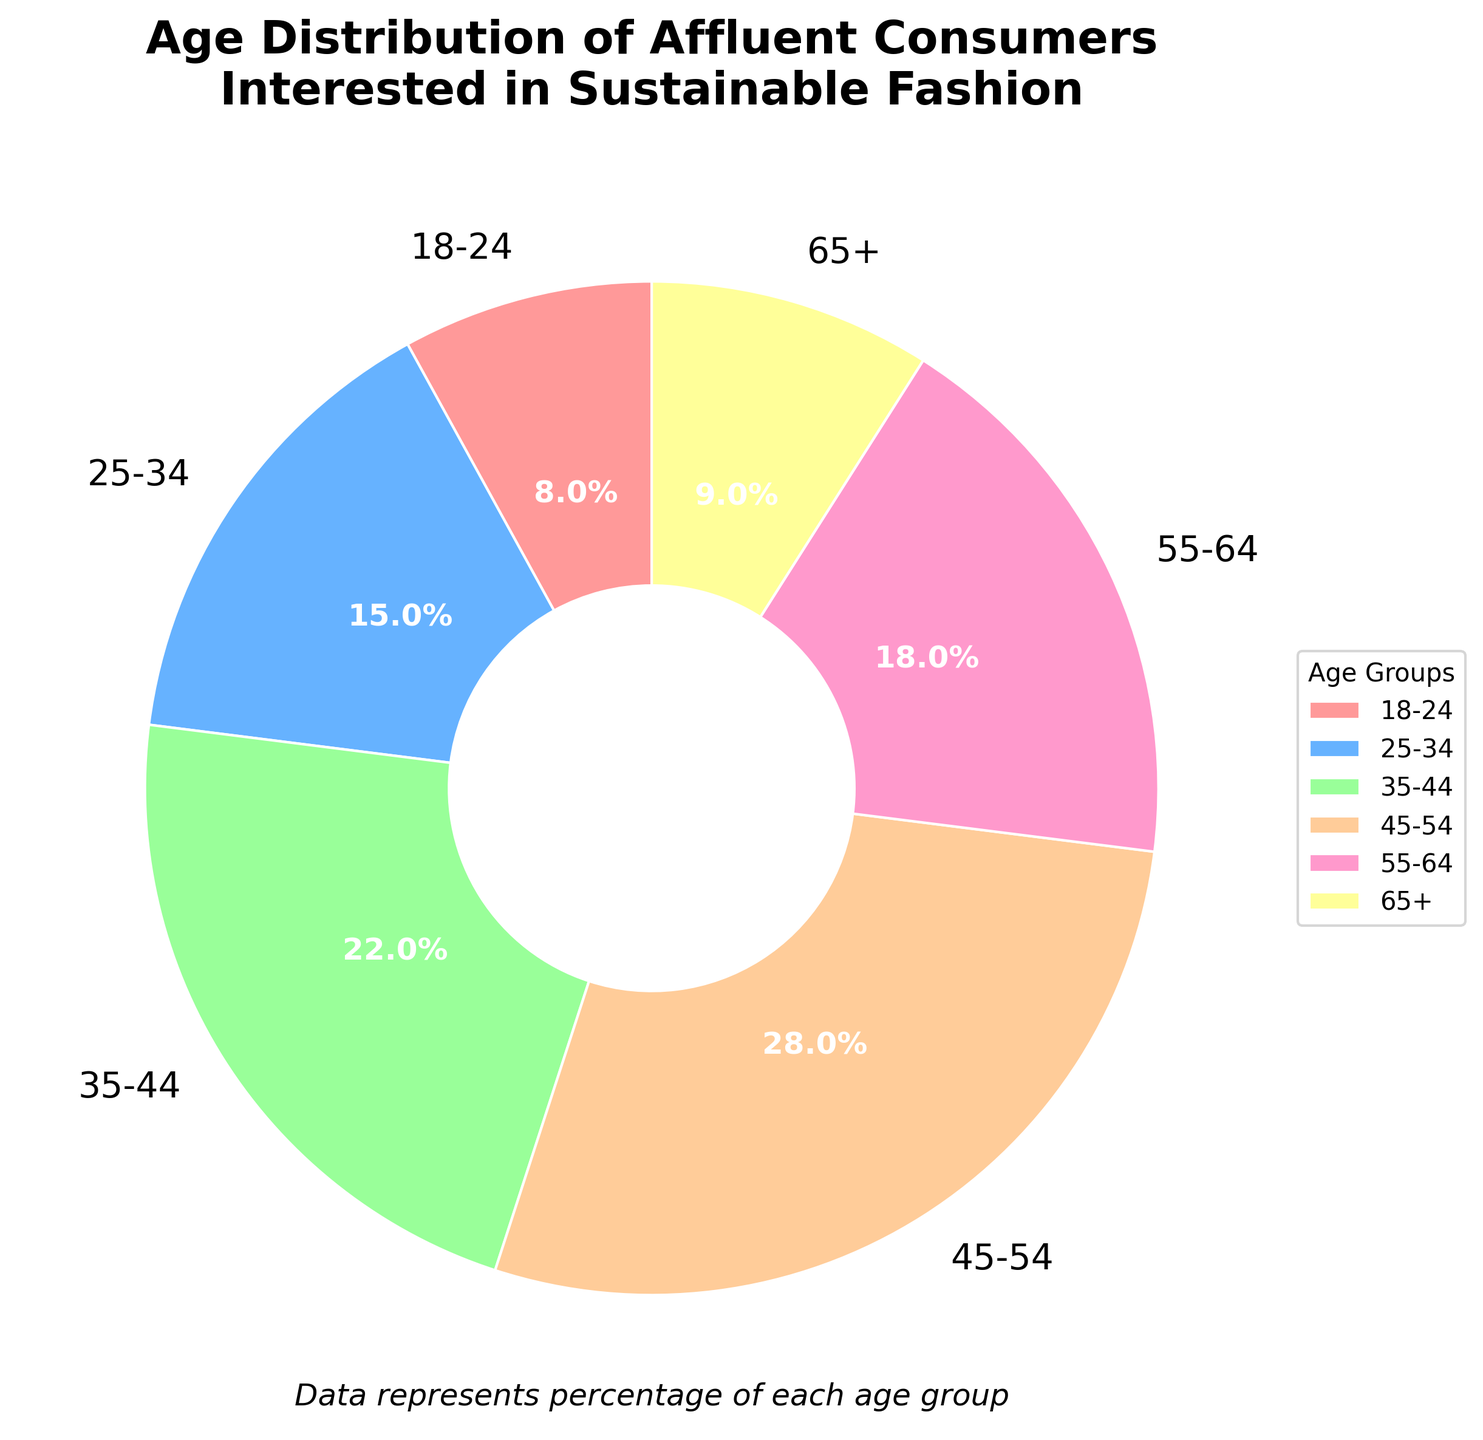Which age group has the highest percentage of affluent consumers interested in sustainable fashion? The pie chart shows that the 45-54 age group has the largest slice, representing the highest percentage.
Answer: 45-54 Which three age groups together make up the majority (over 50%) of affluent consumers? Adding the percentages of the largest contributing groups: 45-54 (28%), 35-44 (22%), and 55-64 (18%). The sum is 28 + 22 + 18 = 68%.
Answer: 45-54, 35-44, 55-64 What is the difference in percentage between the age groups 25-34 and 55-64? The percentage for 55-64 is 18% and for 25-34 is 15%. The difference is 18% - 15% = 3%.
Answer: 3% How does the percentage of the youngest age group (18-24) compare to the oldest age group (65+)? The pie chart shows 8% for the 18-24 group and 9% for the 65+ group. Hence, the 65+ age group has a 1% higher percentage.
Answer: The 65+ group is 1% higher Which age group is represented by the green color in the pie chart? The green color represents the 55-64 age group.
Answer: 55-64 What is the total percentage of consumers aged 25-44? Summing the percentages for 25-34 (15%) and 35-44 (22%) results in 15 + 22 = 37%.
Answer: 37% By how much does the percentage of the 45-54 age group exceed the combination of the youngest and oldest age groups? The percentages for 18-24 is 8% and for 65+ is 9%, giving a sum of 8 + 9 = 17%. The 45-54 group has 28%, so the difference is 28 - 17 = 11%.
Answer: 11% What is the average percentage of the four largest age groups? The largest age groups are 45-54 (28%), 35-44 (22%), 55-64 (18%), and 25-34 (15%). The sum is 28 + 22 + 18 + 15 = 83%. The average is 83 / 4 = 20.75%.
Answer: 20.75% Which age groups collectively contribute most to the pie chart's lower half, visually assessed? The lower half visually includes the 18-24, 25-34, and 65+ age groups, summing 8% (18-24), 15% (25-34), and 9% (65+), which is a total of 32%.
Answer: 18-24, 25-34, 65+ What percentage of consumers is aged below 35? Adding the percentages for 18-24 (8%) and 25-34 (15%) results in 8 + 15 = 23%.
Answer: 23% 